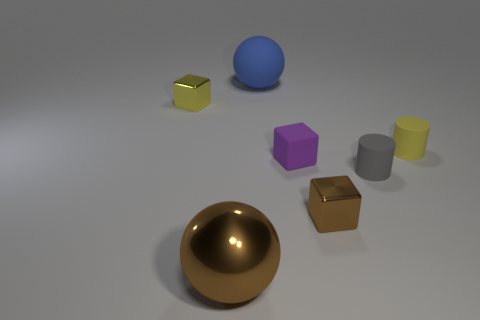Which objects are reflective in the image, and can you describe their shapes? In the image, the gold sphere and the gold cube appear to be reflective. The sphere is a perfect 3D circular object, while the cube has equal square faces and sharp edges. 